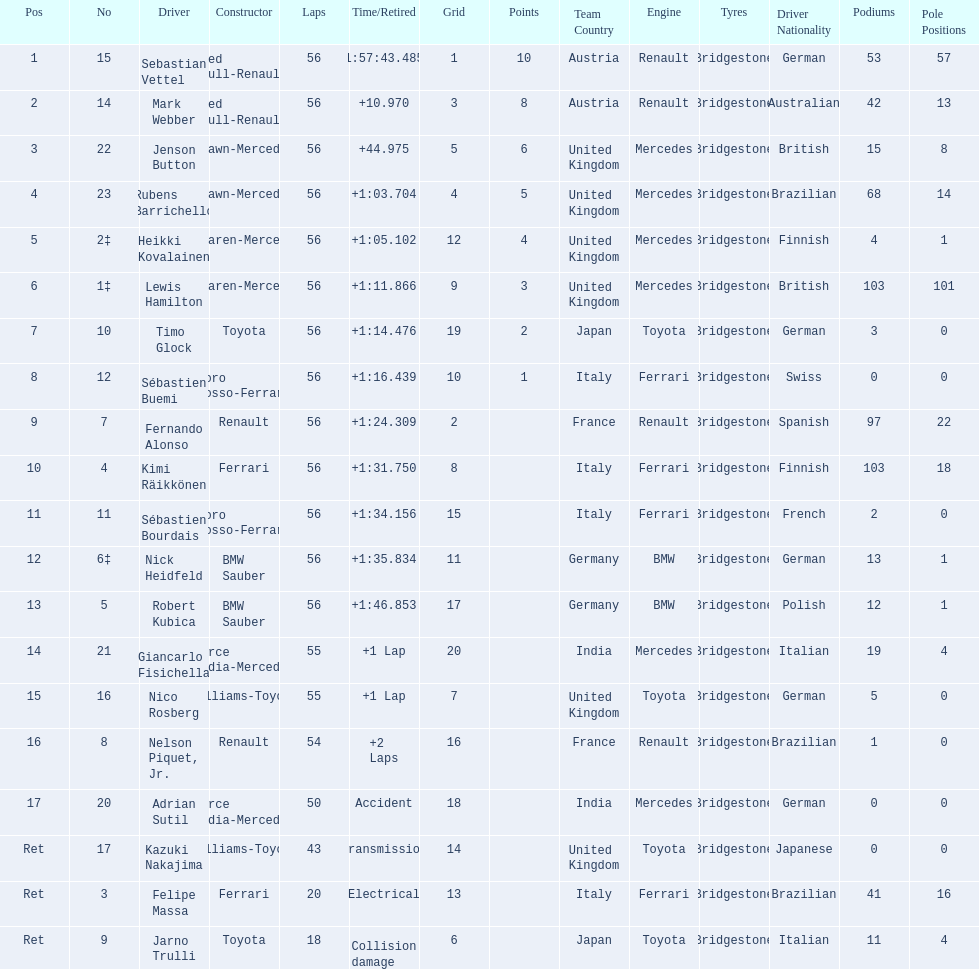Which drive retired because of electrical issues? Felipe Massa. Which driver retired due to accident? Adrian Sutil. Which driver retired due to collision damage? Jarno Trulli. 